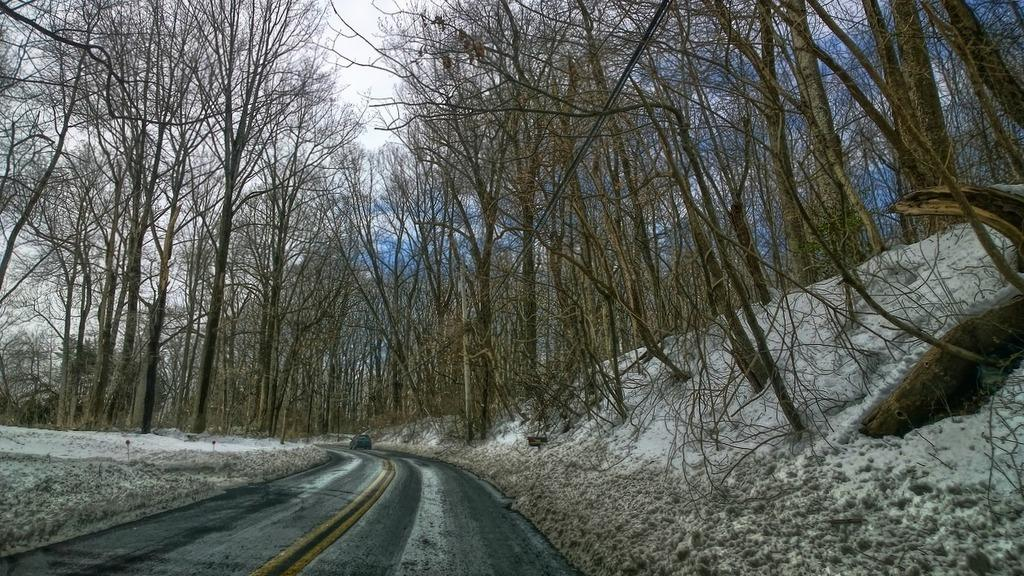What is the main subject of the image? There is a car on the road in the image. What can be seen in the background of the image? Trees and the sky are visible in the background of the image. What is the weather like in the image? There is snow in the image, which suggests a cold or wintery weather. What is the condition of the sky in the image? Clouds are present in the sky. Can you tell me how many worms are crawling on the car in the image? There are no worms present in the image; it features a car on a snowy road with trees and clouds in the background. 